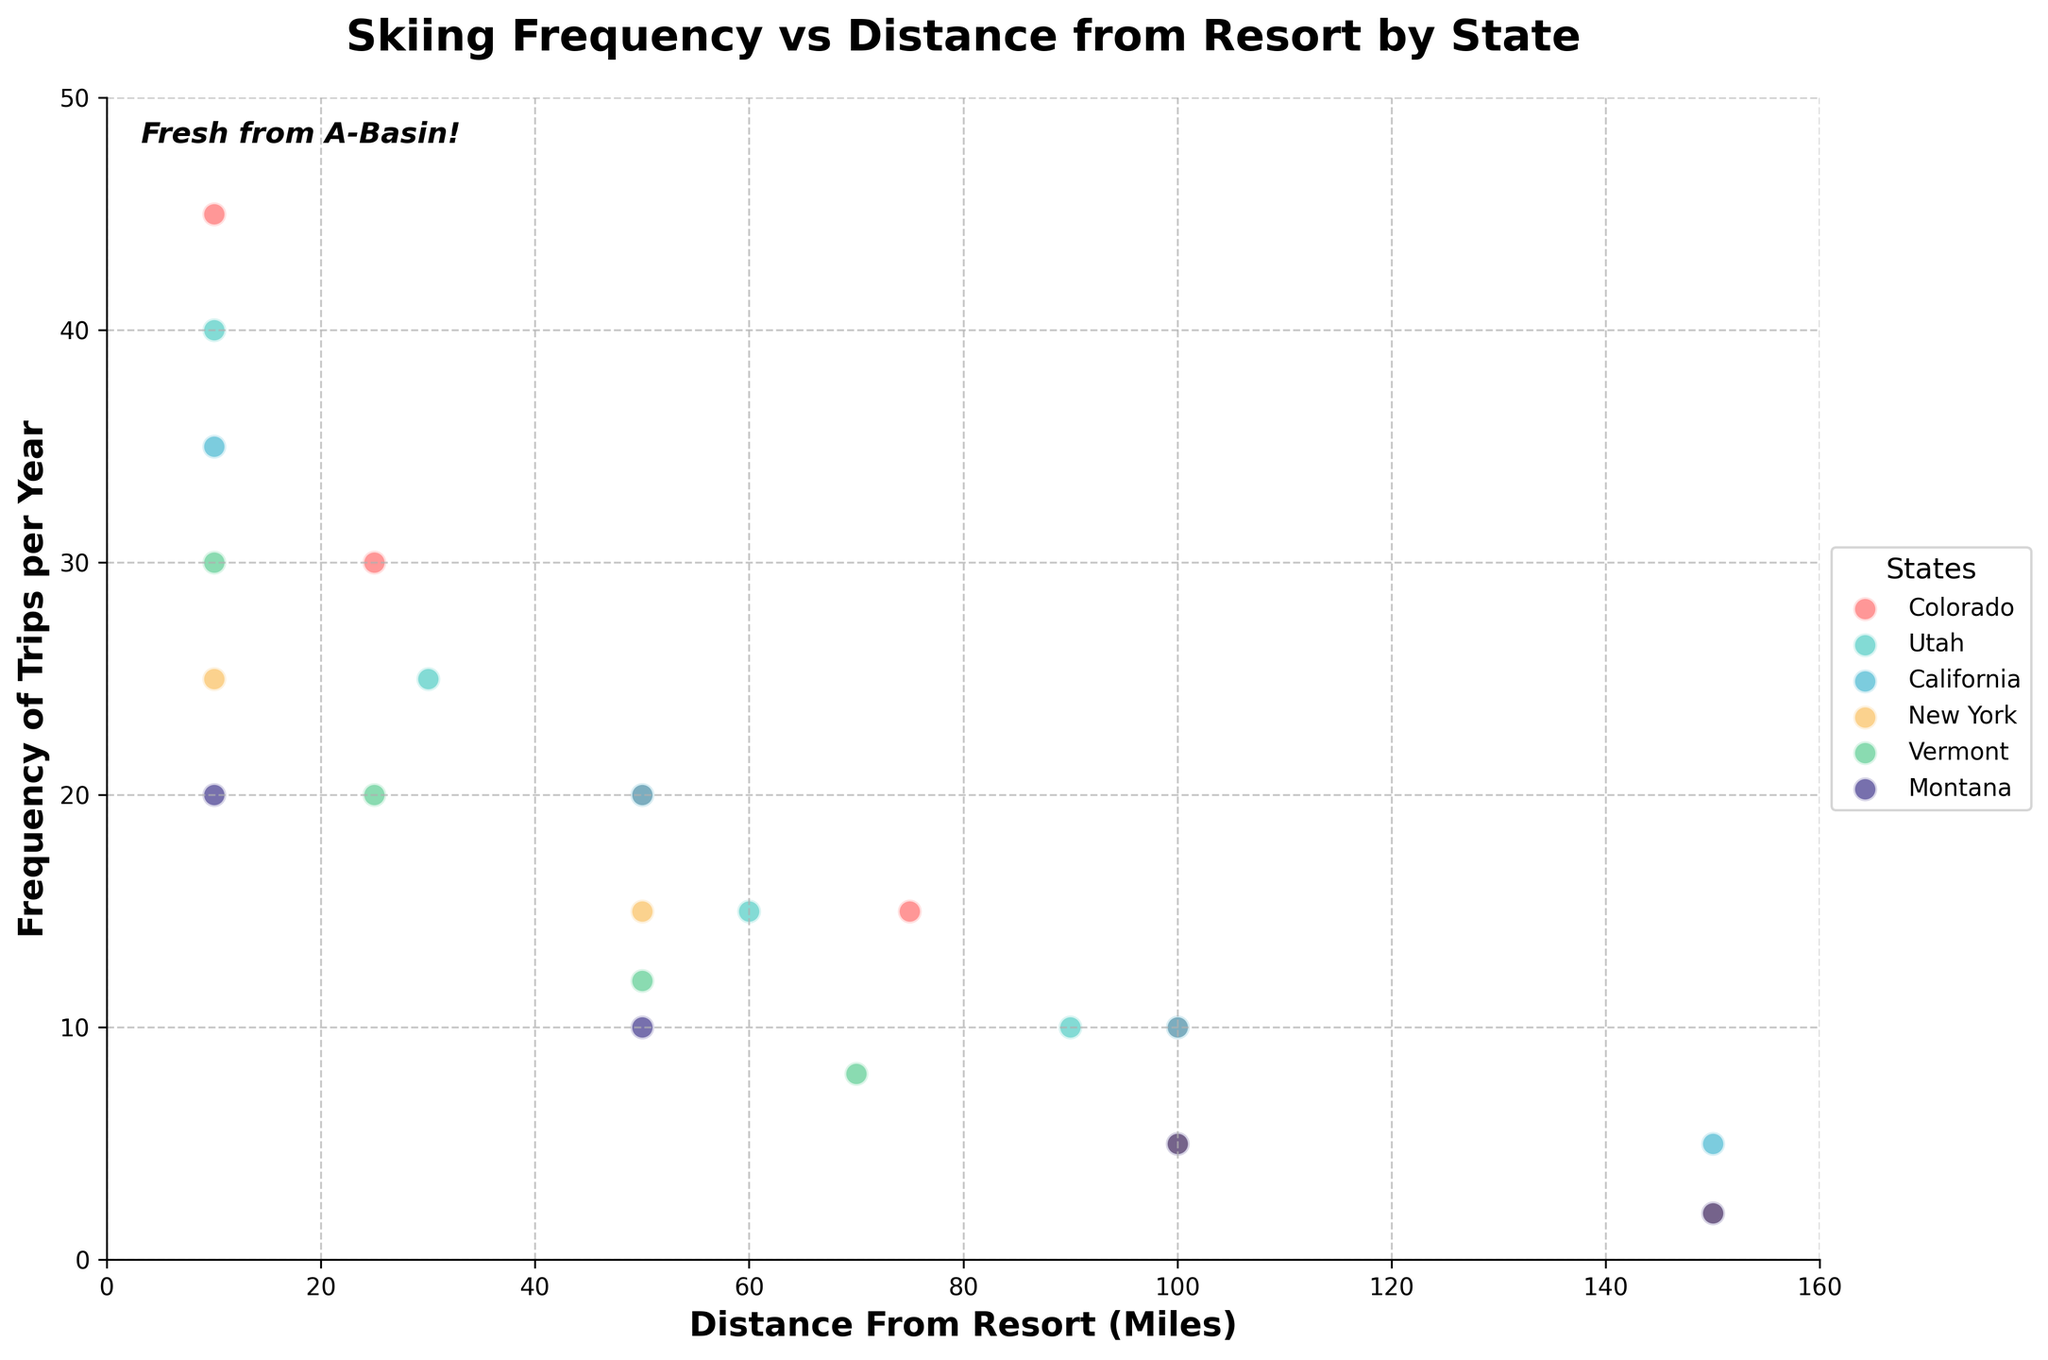what is the title of the figure? The title of the figure is written at the top of the plot, usually in a larger font size and bold text to indicate the main subject of the graph. Based on the code, the title is "Skiing Frequency vs Distance from Resort by State".
Answer: Skiing Frequency vs Distance from Resort by State Which state has the most frequent ski trips at the 10-mile distance from resorts? By comparing the frequency of trips per year at the 10-mile marks for the different states, the highest value can be identified. Colorado has 45 trips, Utah has 40 trips, California has 35 trips, New York has 25 trips, Vermont has 30 trips, and Montana has 20 trips. Colorado has the most frequent ski trips.
Answer: Colorado What is the overall trend observed in skiing frequency as the distance from the resort increases? Observing the scatter plot, it appears that for all states, the general trend is a decrease in skiing frequency as the distance from the resort increases.
Answer: Decreasing What is the average frequency of ski trips per year for residents of Utah? By locating all the data points for Utah and summing them up (40 + 25 + 15 + 10 = 90), then dividing by the number of data points (4), the average frequency is calculated.
Answer: 22.5 Which state has a data point for ski trips at 150 miles, and what are those frequencies? By examining the x-axis at the 150 miles mark, the states California, New York, and Montana have data points. Their corresponding frequencies are 5, 2, and 2 respectively.
Answer: California: 5, New York: 2, Montana: 2 Which state’s skiing frequency decreases most sharply as distance to resort increases? By visually examining the slope of the trend line for each state, Colorado shows the most significant decrease from 45 trips at 10 miles to 10 trips at 100 miles, indicating a steep decline.
Answer: Colorado What is the difference in skiing frequency between residents of California and Vermont at a 50-mile distance? The frequency of ski trips for California at 50 miles is 20 trips per year, and for Vermont, it is 12 trips per year. The difference is 20 - 12 = 8 trips per year.
Answer: 8 Which two states have overlapping data points at 100 miles, and what is the frequency? By looking at the 100-mile distance line, California and Montana both have data points at 5 trips per year, showing the overlap.
Answer: California, Montana: 5 How many states have a ski trip frequency of 10 per year at any distance? By examining the plot, Colorado, Utah, and Montana each have a frequency of 10 trips per year at some distance points.
Answer: 3 